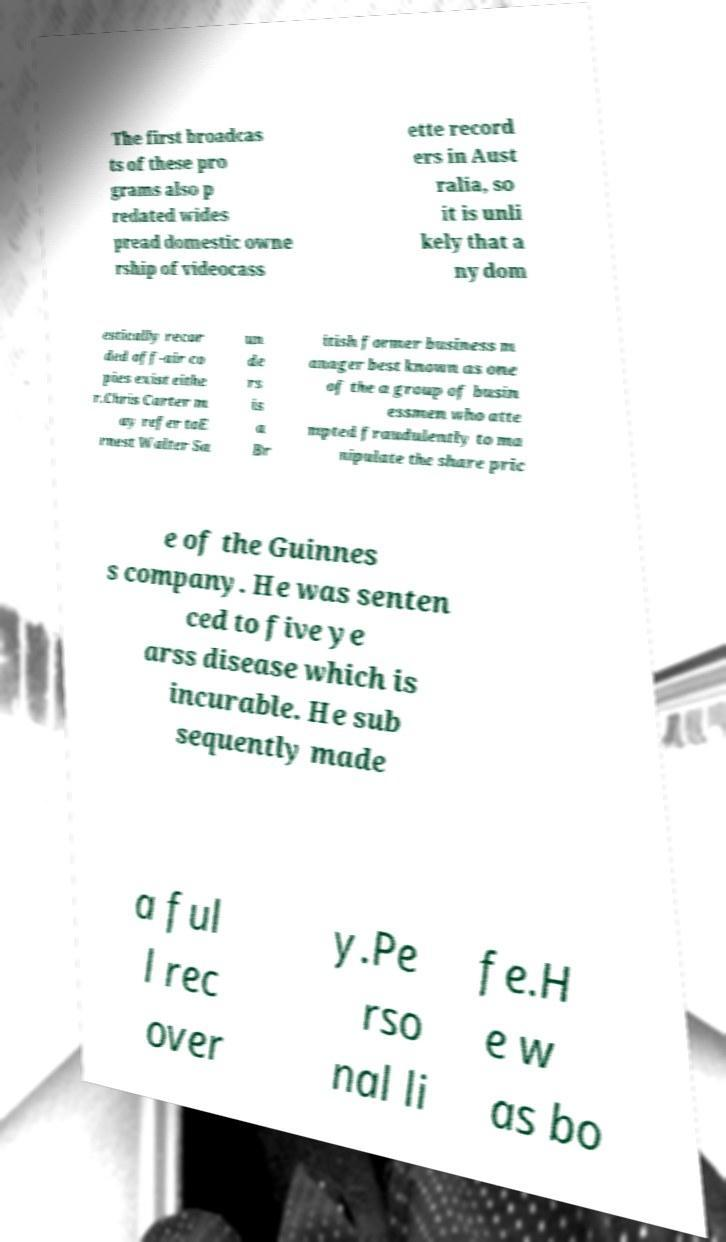There's text embedded in this image that I need extracted. Can you transcribe it verbatim? The first broadcas ts of these pro grams also p redated wides pread domestic owne rship of videocass ette record ers in Aust ralia, so it is unli kely that a ny dom estically recor ded off-air co pies exist eithe r.Chris Carter m ay refer toE rnest Walter Sa un de rs is a Br itish former business m anager best known as one of the a group of busin essmen who atte mpted fraudulently to ma nipulate the share pric e of the Guinnes s company. He was senten ced to five ye arss disease which is incurable. He sub sequently made a ful l rec over y.Pe rso nal li fe.H e w as bo 